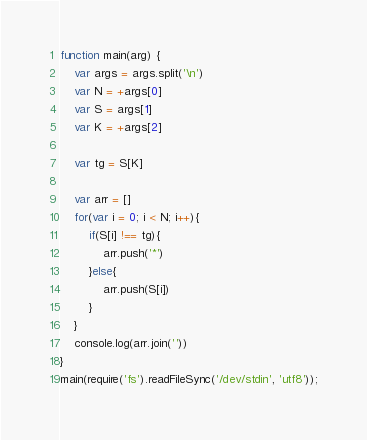<code> <loc_0><loc_0><loc_500><loc_500><_JavaScript_>function main(arg) {
    var args = args.split('\n')
    var N = +args[0]
    var S = args[1]
    var K = +args[2]
 
    var tg = S[K]
 
    var arr = []
    for(var i = 0; i < N; i++){
        if(S[i] !== tg){
            arr.push('*')
        }else{
            arr.push(S[i])
        } 
    }
    console.log(arr.join(''))
}
main(require('fs').readFileSync('/dev/stdin', 'utf8'));</code> 